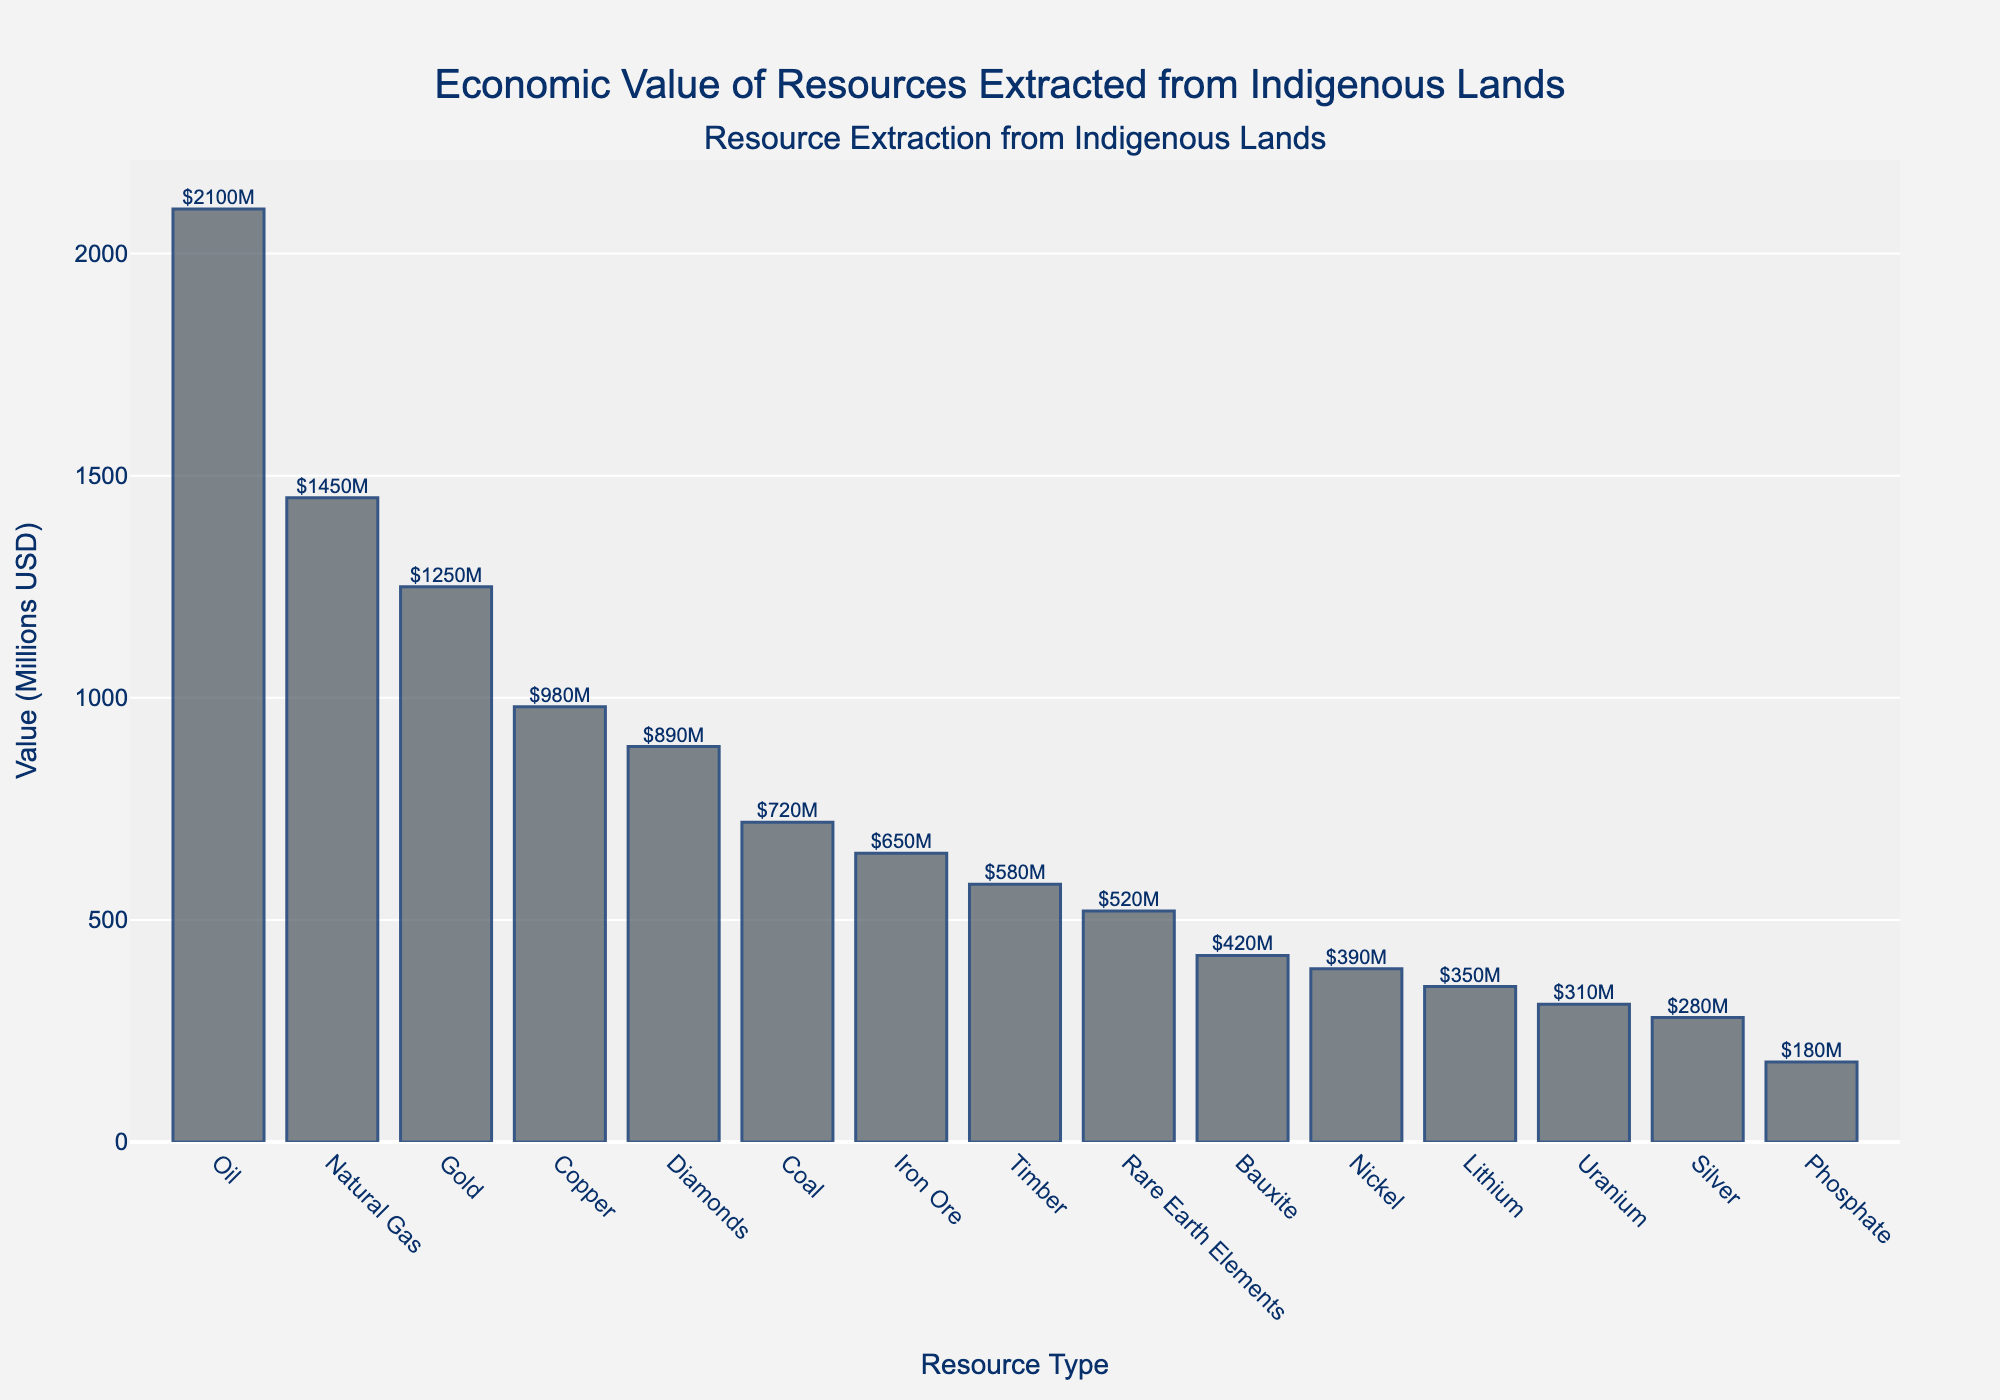What is the resource type with the highest monetary value of extraction from indigenous lands? Look at the bar with the greatest height. The bar for "Oil" is the tallest, indicating it has the highest monetary value.
Answer: Oil How much more is the value of Oil extraction compared to Gold extraction? Find the values for Oil and Gold, which are $2100M and $1250M respectively. Subtract the value of Gold from Oil: $2100M - $1250M = $850M.
Answer: $850M What is the average value of the top three resources extracted from indigenous lands? Identify the top three resources by value: Oil ($2100M), Natural Gas ($1450M), and Gold ($1250M). Sum these values: $2100M + $1450M + $1250M = $4800M. Then, divide by 3: $4800M / 3 = $1600M.
Answer: $1600M Which resource type has the second smallest monetary value and what is that value? Look at the second shortest bar, which corresponds to Phosphate. Its value is $180M.
Answer: Phosphate, $180M How many resource types have a value of extraction less than $500 million? Count the bars with values less than $500M. There are 6 resource types: Timber ($580M), Uranium ($310M), Silver ($280M), Nickel ($390M), Lithium ($350M), and Phosphate ($180M).
Answer: 6 Compare the value of Copper extraction to that of Diamonds extraction. Which one is greater and by how much? Identify the values for Copper ($980M) and Diamonds ($890M). Subtract the value of Diamonds from Copper: $980M - $890M = $90M.
Answer: Copper by $90M What is the total monetary value of the resources whose individual values exceed $1000M? Identify resources with values over $1000M: Oil ($2100M), Natural Gas ($1450M), and Gold ($1250M). Summing these values: $2100M + $1450M + $1250M = $4800M.
Answer: $4800M Which pair of resource types have a combined value closest to $1100 million? Check the sum of combinations: Nickel ($390M) + Bauxite ($420M) = $810M; Bauxite ($420M) + Silver ($280M) = $700M; Iron Ore ($650M) + Phosphate ($180M) = $830M. The closest pair is Iron Ore and Phosphate.
Answer: Iron Ore and Phosphate Calculate the median value of the resource types extracted from indigenous lands. Arrange values in order: $180M, $280M, $310M, $350M, $390M, $420M, $520M, $580M, $650M, $720M, $890M, $980M, $1250M, $1450M, $2100M. The median is the middle value in this list: $520M.
Answer: $520M 